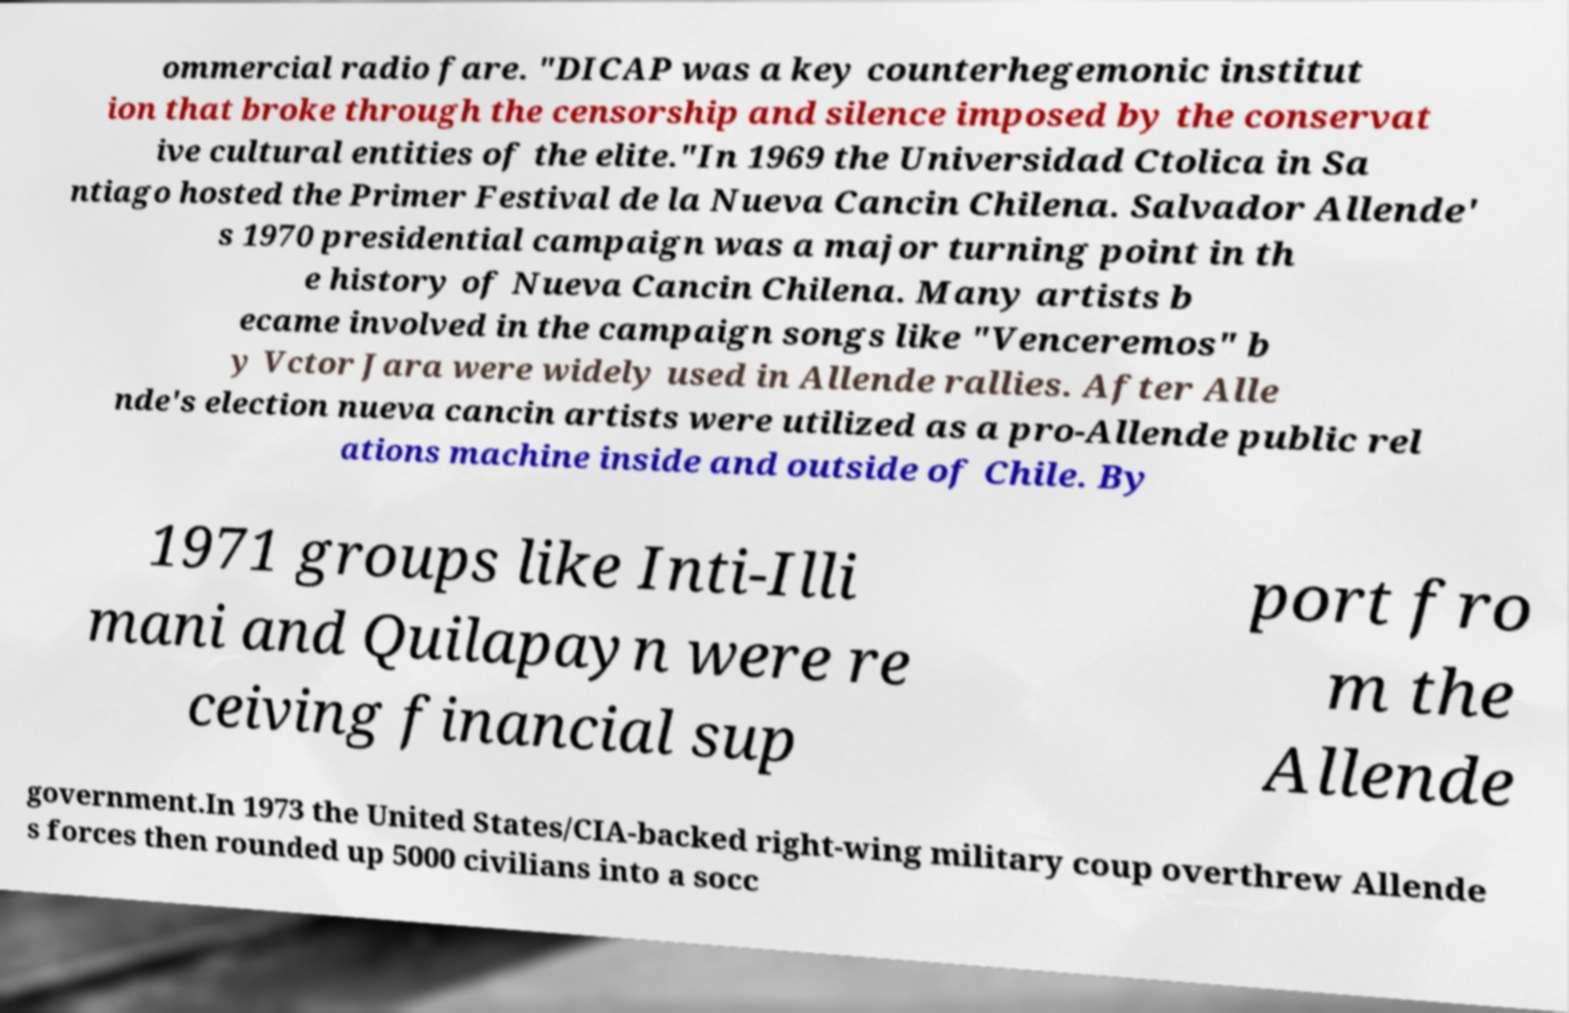Could you extract and type out the text from this image? ommercial radio fare. "DICAP was a key counterhegemonic institut ion that broke through the censorship and silence imposed by the conservat ive cultural entities of the elite."In 1969 the Universidad Ctolica in Sa ntiago hosted the Primer Festival de la Nueva Cancin Chilena. Salvador Allende' s 1970 presidential campaign was a major turning point in th e history of Nueva Cancin Chilena. Many artists b ecame involved in the campaign songs like "Venceremos" b y Vctor Jara were widely used in Allende rallies. After Alle nde's election nueva cancin artists were utilized as a pro-Allende public rel ations machine inside and outside of Chile. By 1971 groups like Inti-Illi mani and Quilapayn were re ceiving financial sup port fro m the Allende government.In 1973 the United States/CIA-backed right-wing military coup overthrew Allende s forces then rounded up 5000 civilians into a socc 